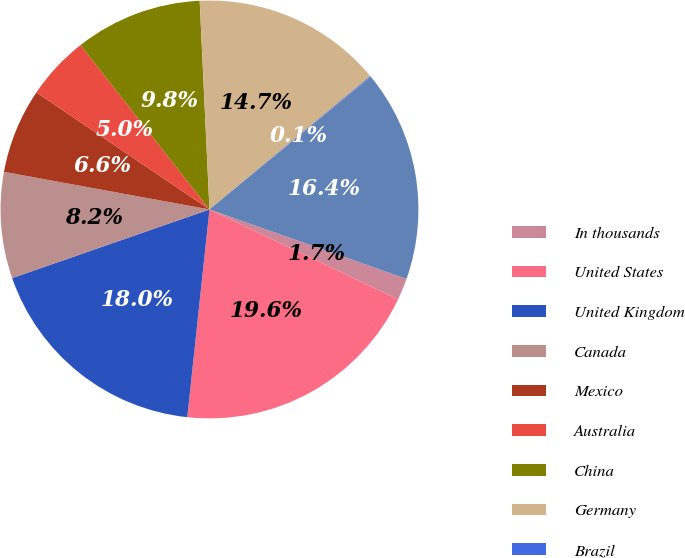<chart> <loc_0><loc_0><loc_500><loc_500><pie_chart><fcel>In thousands<fcel>United States<fcel>United Kingdom<fcel>Canada<fcel>Mexico<fcel>Australia<fcel>China<fcel>Germany<fcel>Brazil<fcel>Italy<nl><fcel>1.69%<fcel>19.61%<fcel>17.98%<fcel>8.21%<fcel>6.58%<fcel>4.95%<fcel>9.84%<fcel>14.73%<fcel>0.06%<fcel>16.35%<nl></chart> 